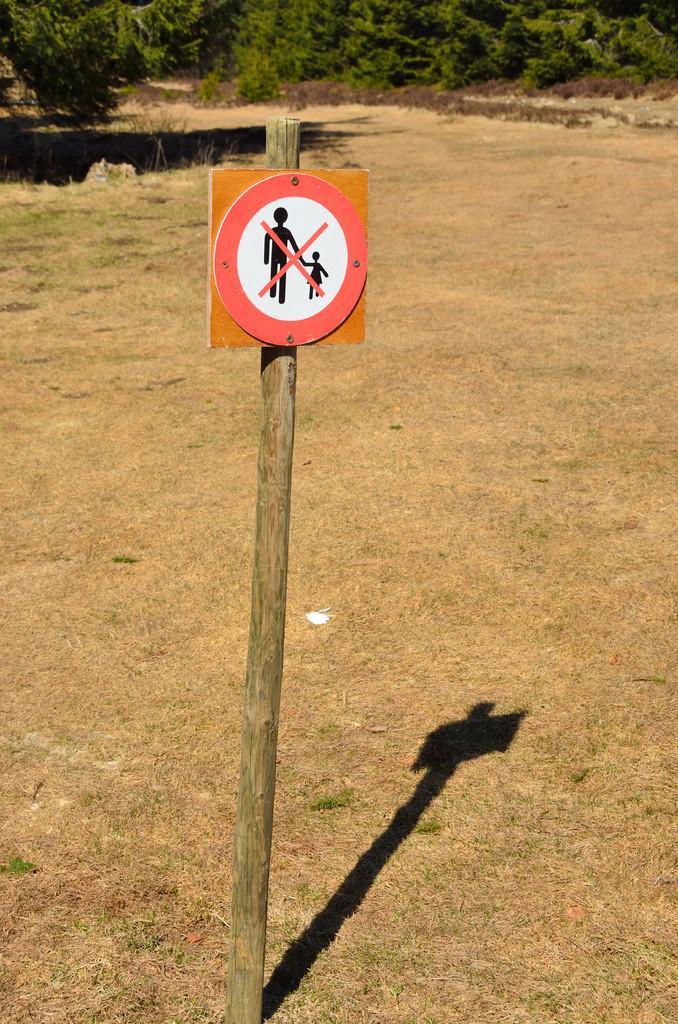In one or two sentences, can you explain what this image depicts? In this image we can see a sign board on a wooden pole. In the background there are trees. On the ground there is grass. 